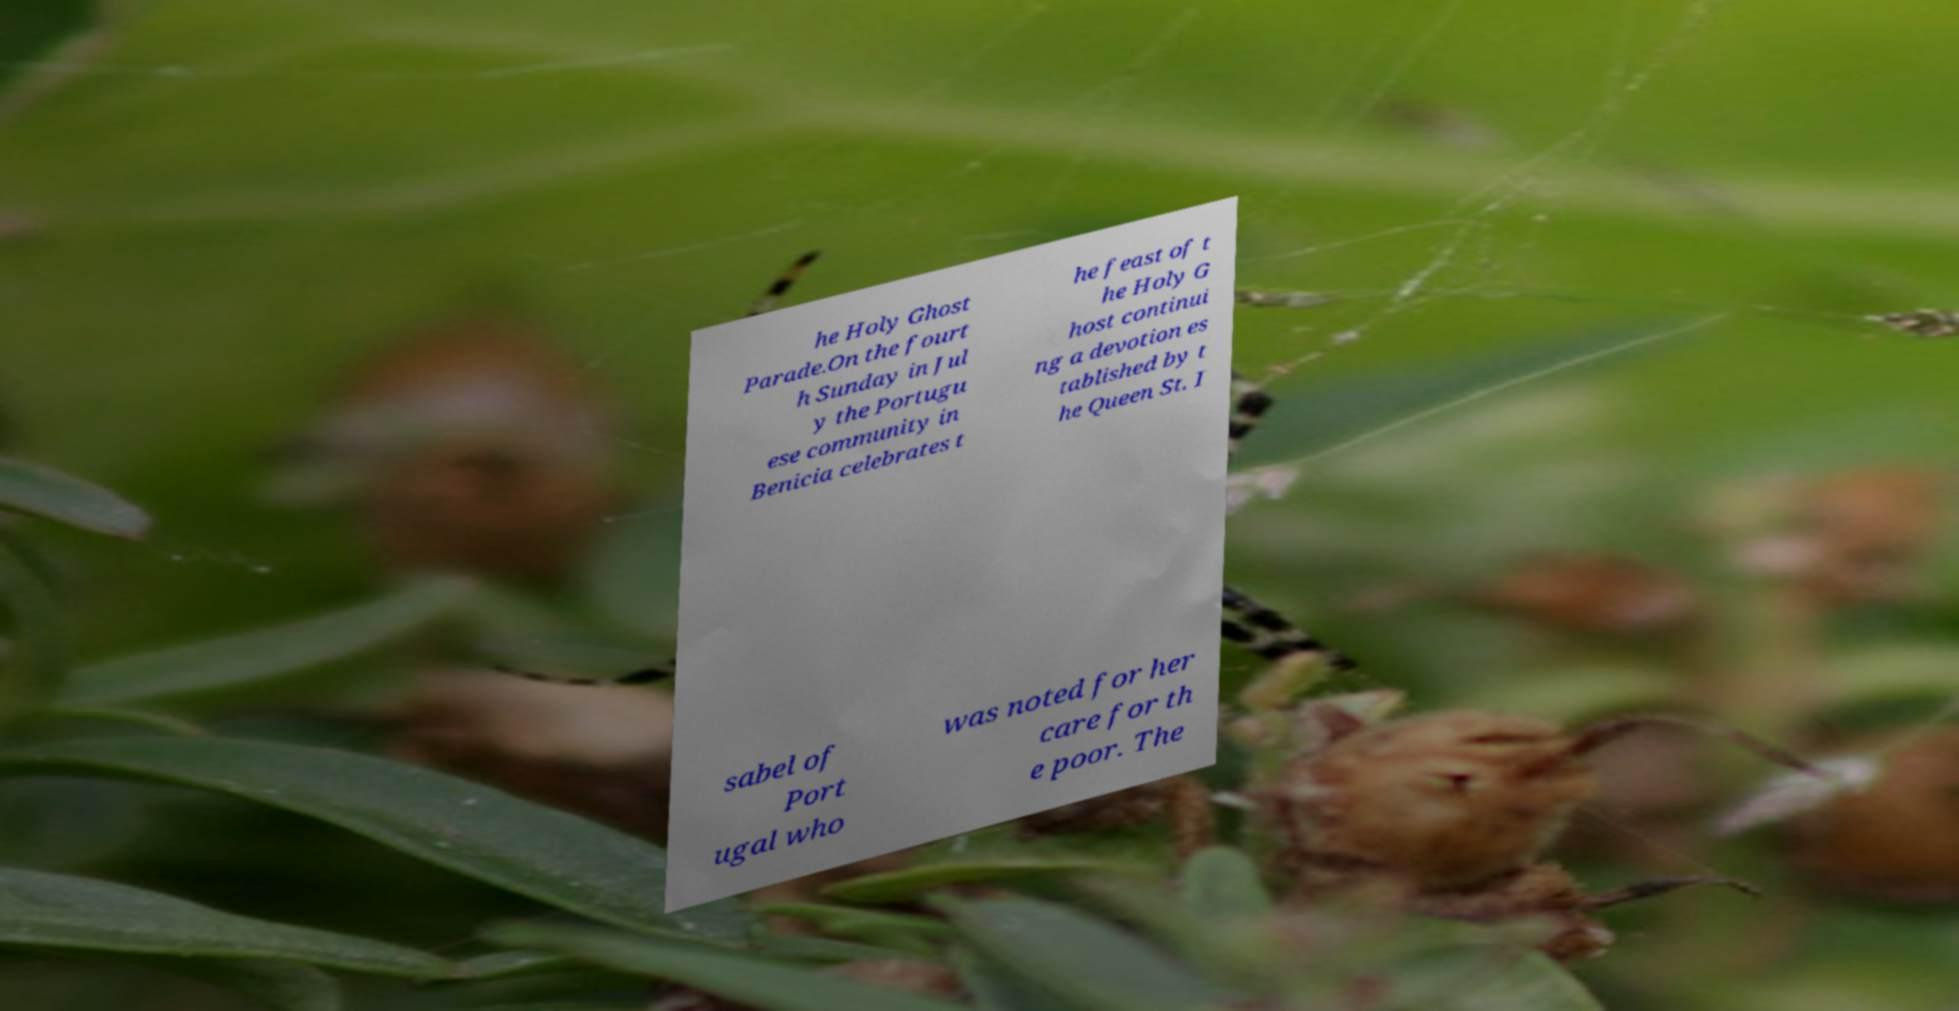Can you accurately transcribe the text from the provided image for me? he Holy Ghost Parade.On the fourt h Sunday in Jul y the Portugu ese community in Benicia celebrates t he feast of t he Holy G host continui ng a devotion es tablished by t he Queen St. I sabel of Port ugal who was noted for her care for th e poor. The 